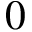Convert formula to latex. <formula><loc_0><loc_0><loc_500><loc_500>0</formula> 